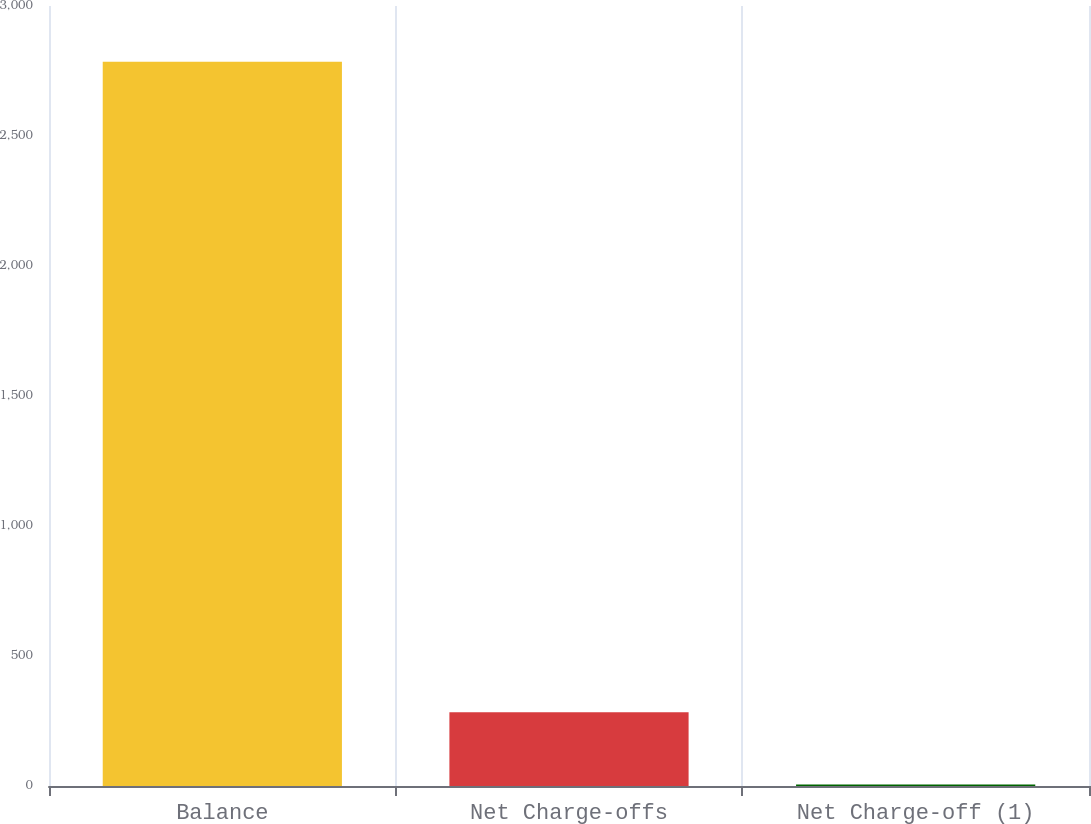Convert chart to OTSL. <chart><loc_0><loc_0><loc_500><loc_500><bar_chart><fcel>Balance<fcel>Net Charge-offs<fcel>Net Charge-off (1)<nl><fcel>2786<fcel>283.96<fcel>5.96<nl></chart> 